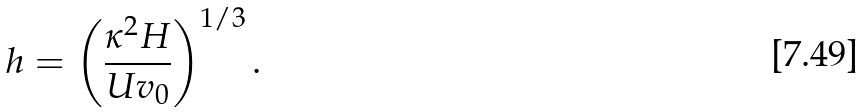Convert formula to latex. <formula><loc_0><loc_0><loc_500><loc_500>h = \left ( \frac { \kappa ^ { 2 } H } { U v _ { 0 } } \right ) ^ { 1 / 3 } .</formula> 